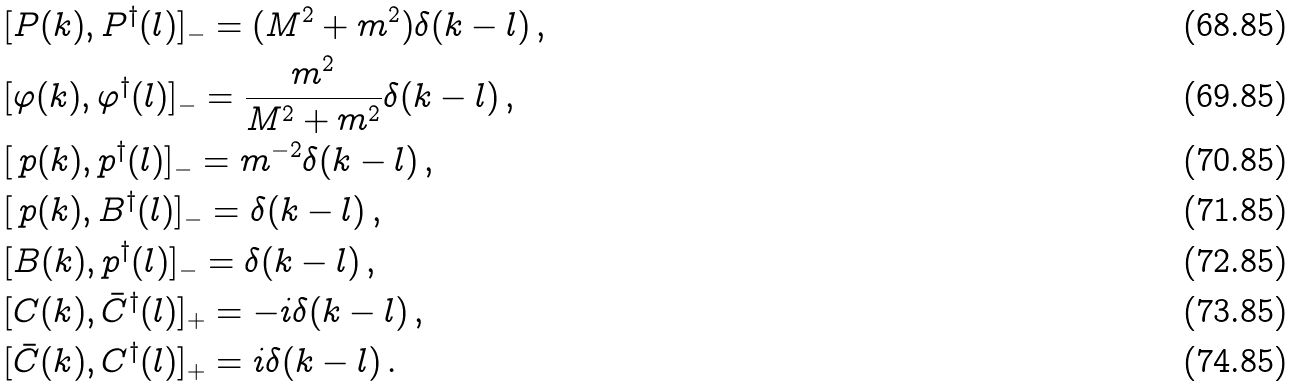Convert formula to latex. <formula><loc_0><loc_0><loc_500><loc_500>& [ P ( k ) , P ^ { \dagger } ( l ) ] _ { - } = ( M ^ { 2 } + m ^ { 2 } ) \delta ( k - l ) \, , \\ & [ \varphi ( k ) , \varphi ^ { \dagger } ( l ) ] _ { - } = \frac { m ^ { 2 } } { M ^ { 2 } + m ^ { 2 } } \delta ( k - l ) \, , \\ & [ \, p ( k ) , p ^ { \dagger } ( l ) ] _ { - } = m ^ { - 2 } \delta ( k - l ) \, , \\ & [ \, p ( k ) , B ^ { \dagger } ( l ) ] _ { - } = \delta ( k - l ) \, , \\ & [ B ( k ) , p ^ { \dagger } ( l ) ] _ { - } = \delta ( k - l ) \, , \\ & [ C ( k ) , \bar { C } ^ { \dagger } ( l ) ] _ { + } = - i \delta ( k - l ) \, , \\ & [ \bar { C } ( k ) , C ^ { \dagger } ( l ) ] _ { + } = i \delta ( k - l ) \, .</formula> 